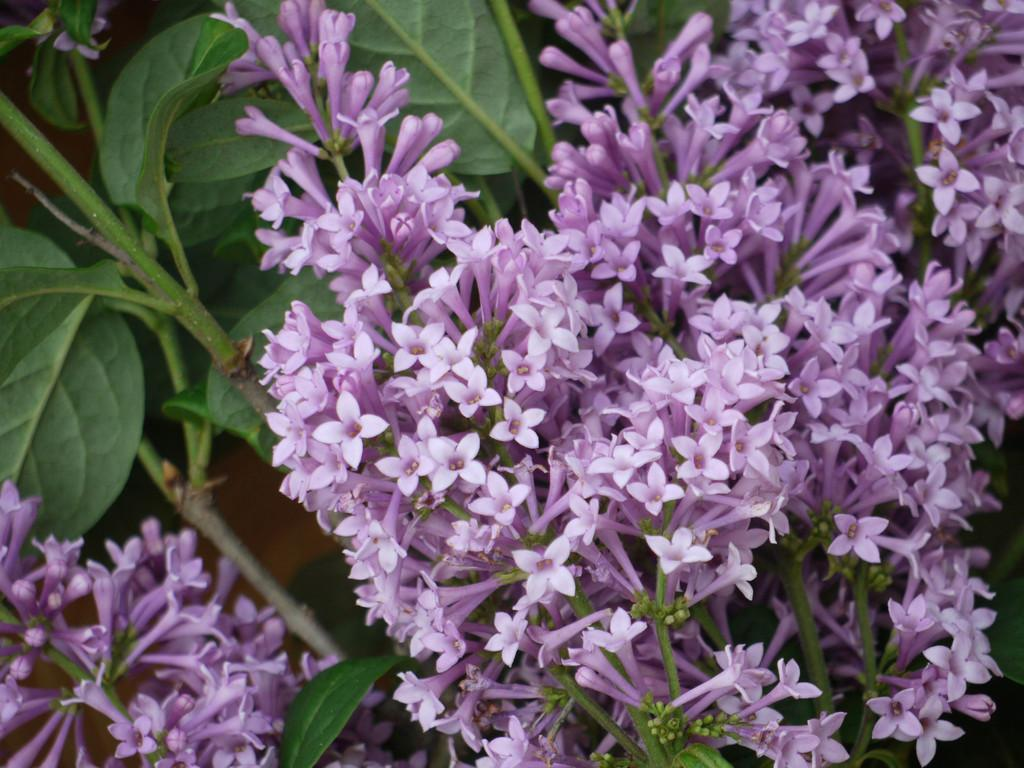What is the main subject of the image? The main subject of the image is a group of flowers. Are there any other elements related to the flowers in the image? Yes, there are leaves in the image. What type of pollution can be seen affecting the flowers in the image? There is no pollution present in the image; it only features a group of flowers and leaves. What part of the rock is visible in the image? There is no rock present in the image; it only features a group of flowers and leaves. 